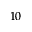<formula> <loc_0><loc_0><loc_500><loc_500>1 0</formula> 